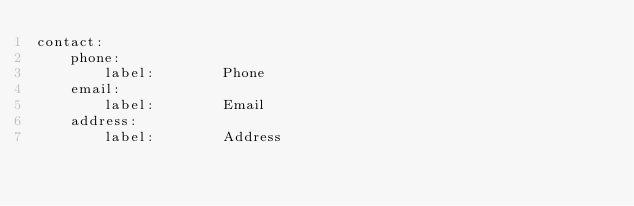Convert code to text. <code><loc_0><loc_0><loc_500><loc_500><_YAML_>contact:
    phone:
        label:        Phone
    email:
        label:        Email
    address:
        label:        Address</code> 